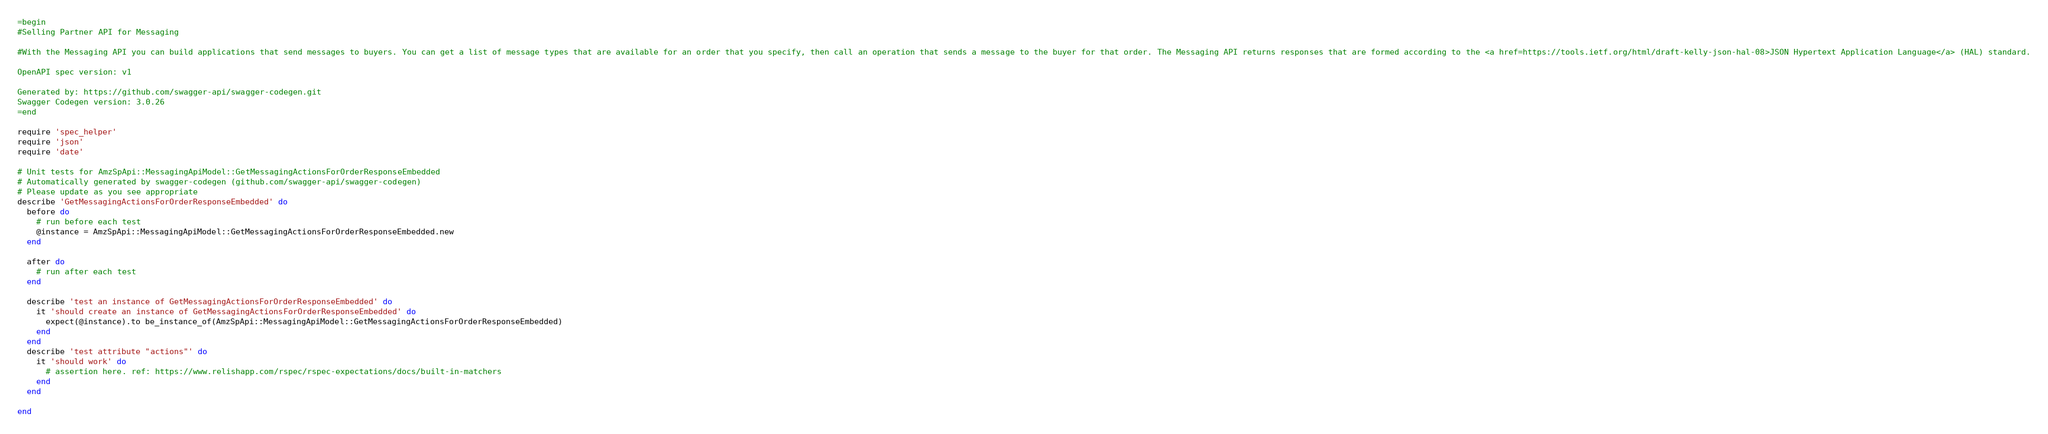<code> <loc_0><loc_0><loc_500><loc_500><_Ruby_>=begin
#Selling Partner API for Messaging

#With the Messaging API you can build applications that send messages to buyers. You can get a list of message types that are available for an order that you specify, then call an operation that sends a message to the buyer for that order. The Messaging API returns responses that are formed according to the <a href=https://tools.ietf.org/html/draft-kelly-json-hal-08>JSON Hypertext Application Language</a> (HAL) standard.

OpenAPI spec version: v1

Generated by: https://github.com/swagger-api/swagger-codegen.git
Swagger Codegen version: 3.0.26
=end

require 'spec_helper'
require 'json'
require 'date'

# Unit tests for AmzSpApi::MessagingApiModel::GetMessagingActionsForOrderResponseEmbedded
# Automatically generated by swagger-codegen (github.com/swagger-api/swagger-codegen)
# Please update as you see appropriate
describe 'GetMessagingActionsForOrderResponseEmbedded' do
  before do
    # run before each test
    @instance = AmzSpApi::MessagingApiModel::GetMessagingActionsForOrderResponseEmbedded.new
  end

  after do
    # run after each test
  end

  describe 'test an instance of GetMessagingActionsForOrderResponseEmbedded' do
    it 'should create an instance of GetMessagingActionsForOrderResponseEmbedded' do
      expect(@instance).to be_instance_of(AmzSpApi::MessagingApiModel::GetMessagingActionsForOrderResponseEmbedded)
    end
  end
  describe 'test attribute "actions"' do
    it 'should work' do
      # assertion here. ref: https://www.relishapp.com/rspec/rspec-expectations/docs/built-in-matchers
    end
  end

end
</code> 